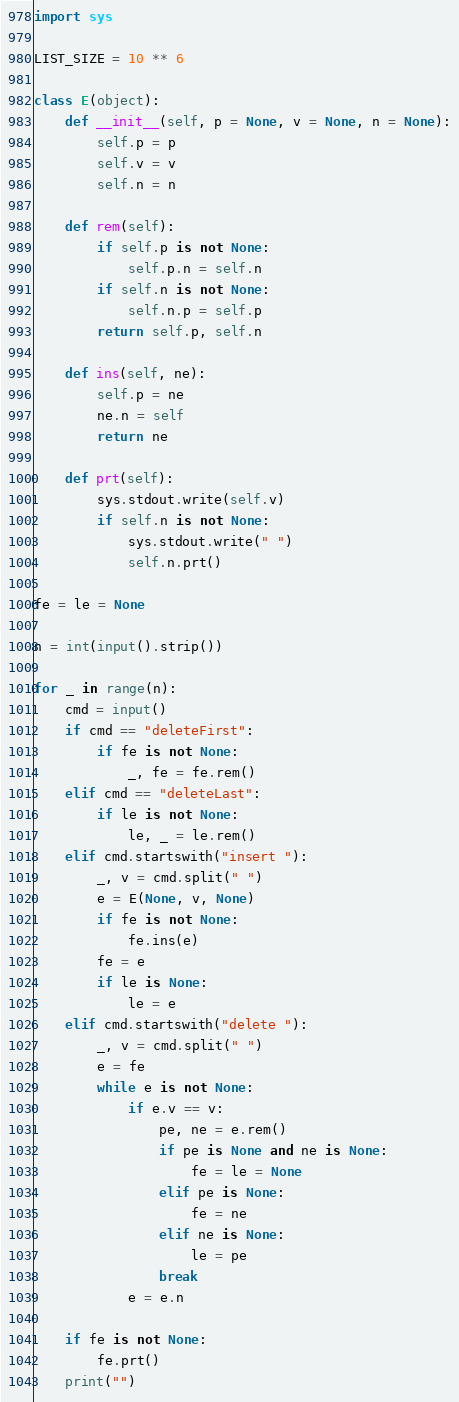<code> <loc_0><loc_0><loc_500><loc_500><_Python_>import sys

LIST_SIZE = 10 ** 6

class E(object):
    def __init__(self, p = None, v = None, n = None):
        self.p = p
        self.v = v
        self.n = n

    def rem(self):
        if self.p is not None:
            self.p.n = self.n
        if self.n is not None:
            self.n.p = self.p
        return self.p, self.n

    def ins(self, ne):
        self.p = ne
        ne.n = self
        return ne

    def prt(self):
        sys.stdout.write(self.v)
        if self.n is not None:
            sys.stdout.write(" ")
            self.n.prt()

fe = le = None

n = int(input().strip())

for _ in range(n):
    cmd = input()
    if cmd == "deleteFirst":
        if fe is not None:
            _, fe = fe.rem()
    elif cmd == "deleteLast":
        if le is not None:
            le, _ = le.rem()
    elif cmd.startswith("insert "):
        _, v = cmd.split(" ")
        e = E(None, v, None)
        if fe is not None:
            fe.ins(e)
        fe = e
        if le is None:
            le = e
    elif cmd.startswith("delete "):
        _, v = cmd.split(" ")
        e = fe
        while e is not None:
            if e.v == v:
                pe, ne = e.rem()
                if pe is None and ne is None:
                    fe = le = None
                elif pe is None:
                    fe = ne
                elif ne is None:
                    le = pe
                break
            e = e.n

    if fe is not None:
        fe.prt()
    print("")</code> 